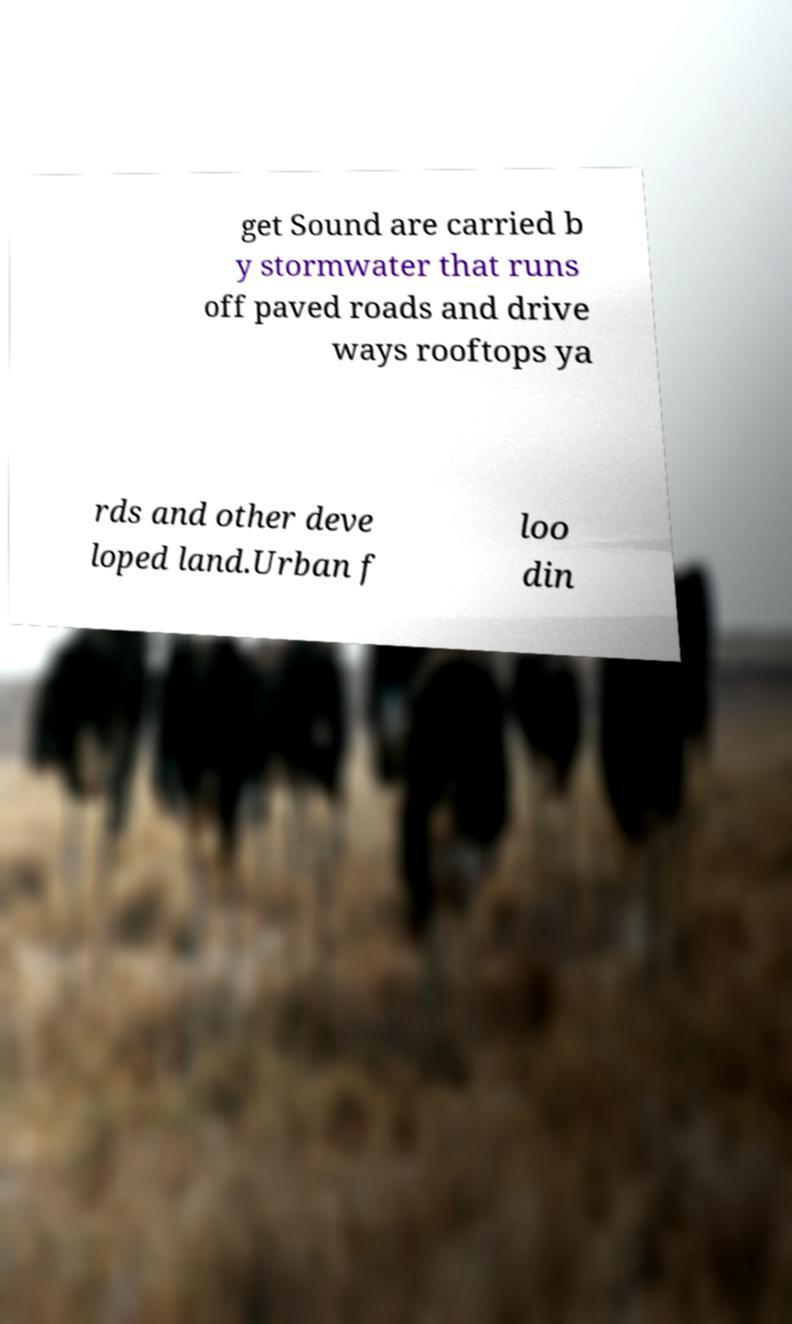Can you read and provide the text displayed in the image?This photo seems to have some interesting text. Can you extract and type it out for me? get Sound are carried b y stormwater that runs off paved roads and drive ways rooftops ya rds and other deve loped land.Urban f loo din 